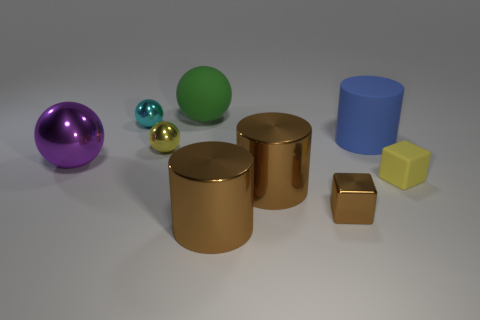Are there any blue matte cylinders of the same size as the purple metal thing?
Offer a terse response. Yes. The other big thing that is the same shape as the green object is what color?
Provide a succinct answer. Purple. Is the size of the cube on the left side of the small yellow cube the same as the cylinder that is behind the big purple object?
Provide a succinct answer. No. Are there any large brown metal things of the same shape as the yellow metallic thing?
Offer a very short reply. No. Are there an equal number of tiny yellow things that are behind the matte ball and green matte things?
Ensure brevity in your answer.  No. Do the brown block and the cylinder behind the yellow rubber cube have the same size?
Offer a very short reply. No. How many big purple balls are the same material as the large green sphere?
Offer a terse response. 0. Is the size of the matte cube the same as the green rubber object?
Ensure brevity in your answer.  No. Is there anything else that is the same color as the big rubber sphere?
Your response must be concise. No. There is a rubber thing that is behind the tiny yellow sphere and on the right side of the big green matte object; what shape is it?
Ensure brevity in your answer.  Cylinder. 